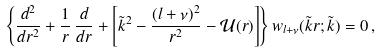<formula> <loc_0><loc_0><loc_500><loc_500>\left \{ \frac { d ^ { 2 } } { d r ^ { 2 } } + \frac { 1 } { r } \, \frac { d } { d r } + \left [ \tilde { k } ^ { 2 } - \frac { ( l + \nu ) ^ { 2 } } { r ^ { 2 } } - { \mathcal { U } } ( r ) \right ] \right \} w _ { l + \nu } ( \tilde { k } r ; \tilde { k } ) = 0 \, ,</formula> 